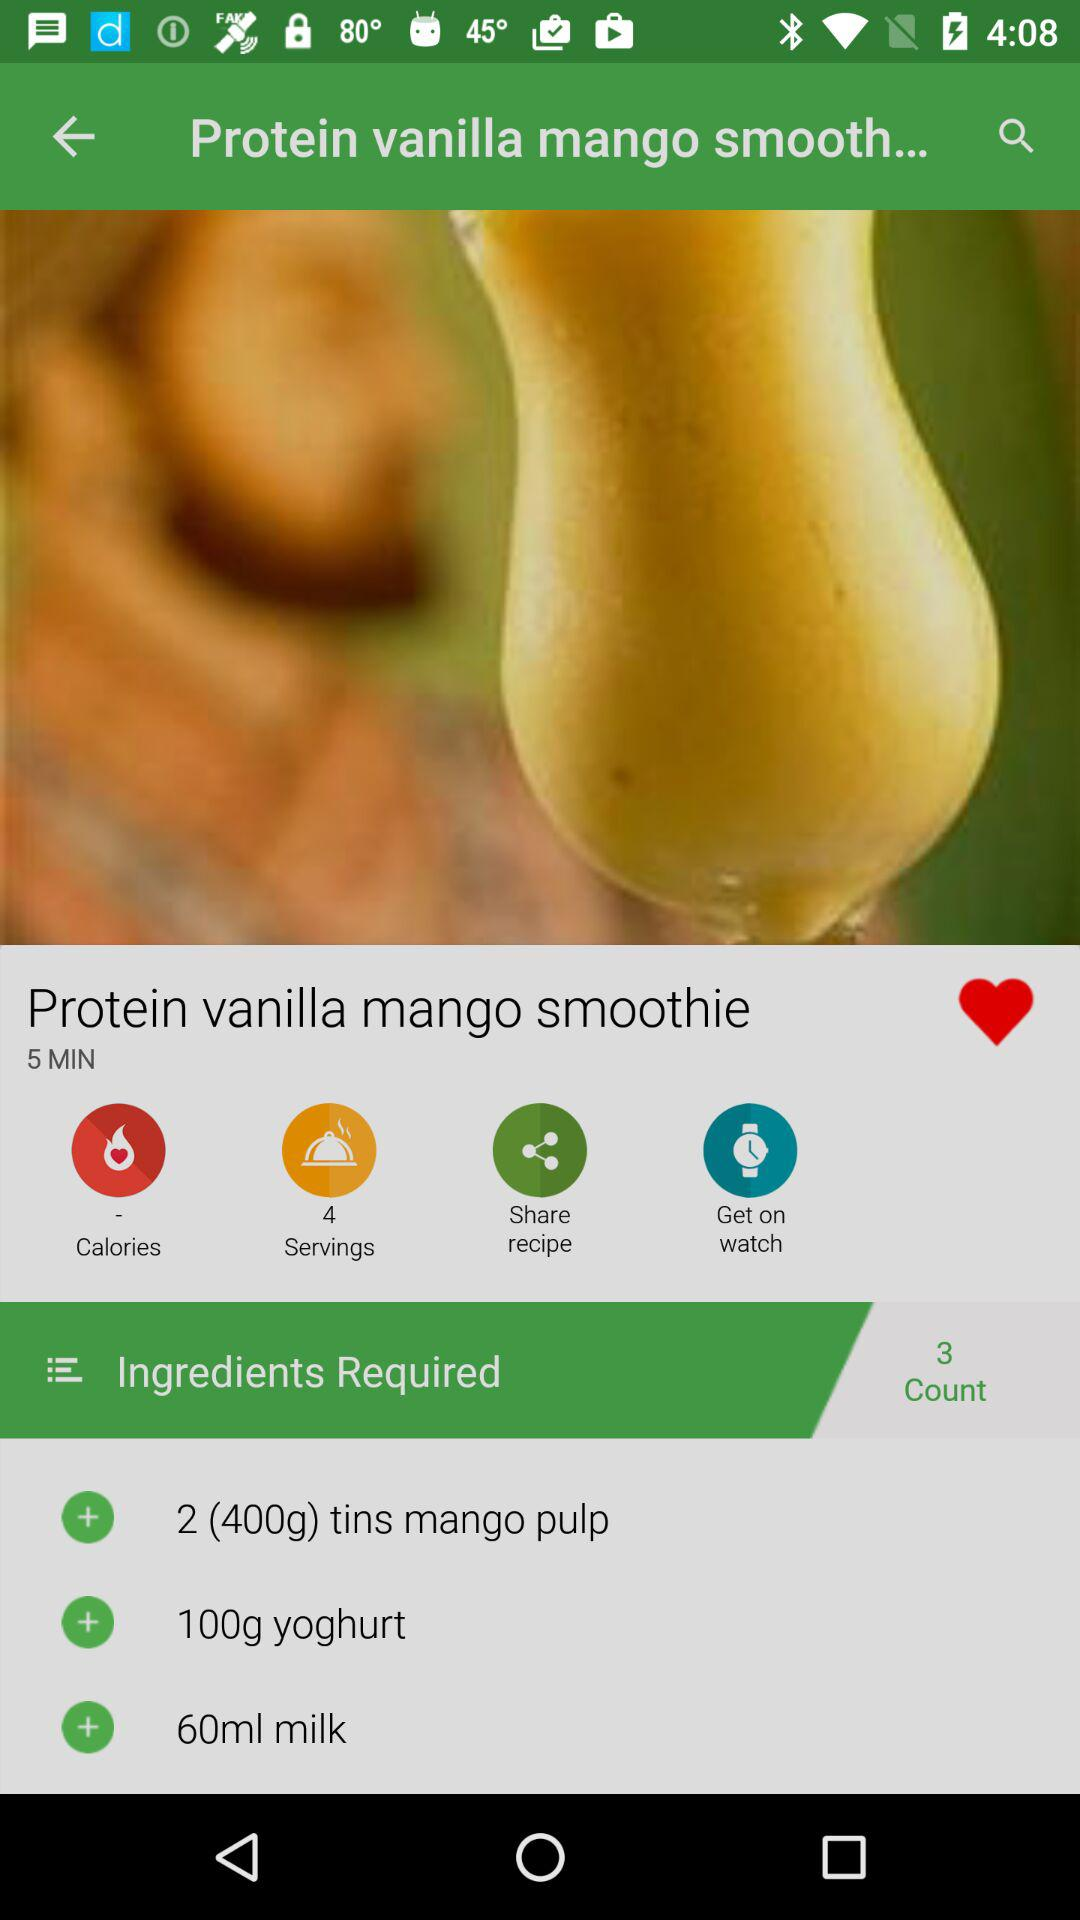How much mango pulp is required? There are 400 grams of mango pulp required. 